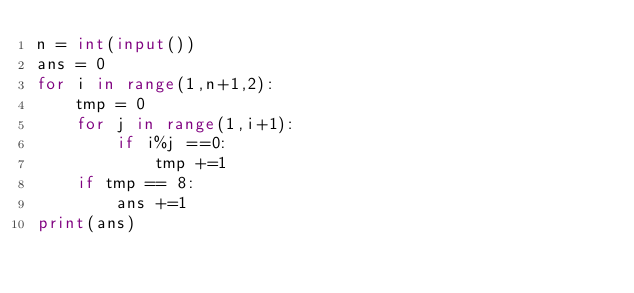Convert code to text. <code><loc_0><loc_0><loc_500><loc_500><_Python_>n = int(input())
ans = 0
for i in range(1,n+1,2):
    tmp = 0
    for j in range(1,i+1):
        if i%j ==0:
            tmp +=1
    if tmp == 8:
        ans +=1
print(ans)</code> 